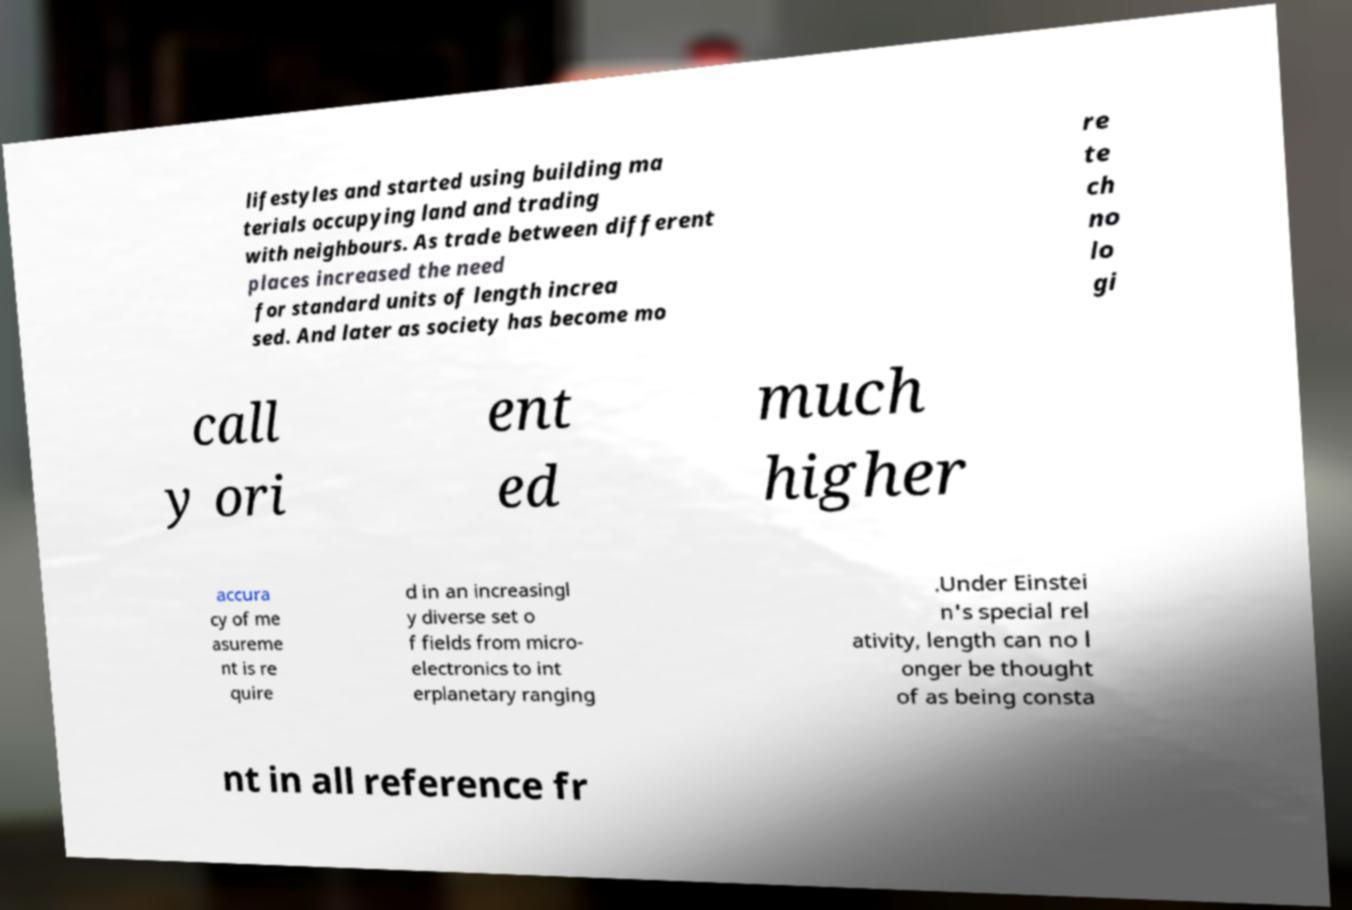I need the written content from this picture converted into text. Can you do that? lifestyles and started using building ma terials occupying land and trading with neighbours. As trade between different places increased the need for standard units of length increa sed. And later as society has become mo re te ch no lo gi call y ori ent ed much higher accura cy of me asureme nt is re quire d in an increasingl y diverse set o f fields from micro- electronics to int erplanetary ranging .Under Einstei n's special rel ativity, length can no l onger be thought of as being consta nt in all reference fr 